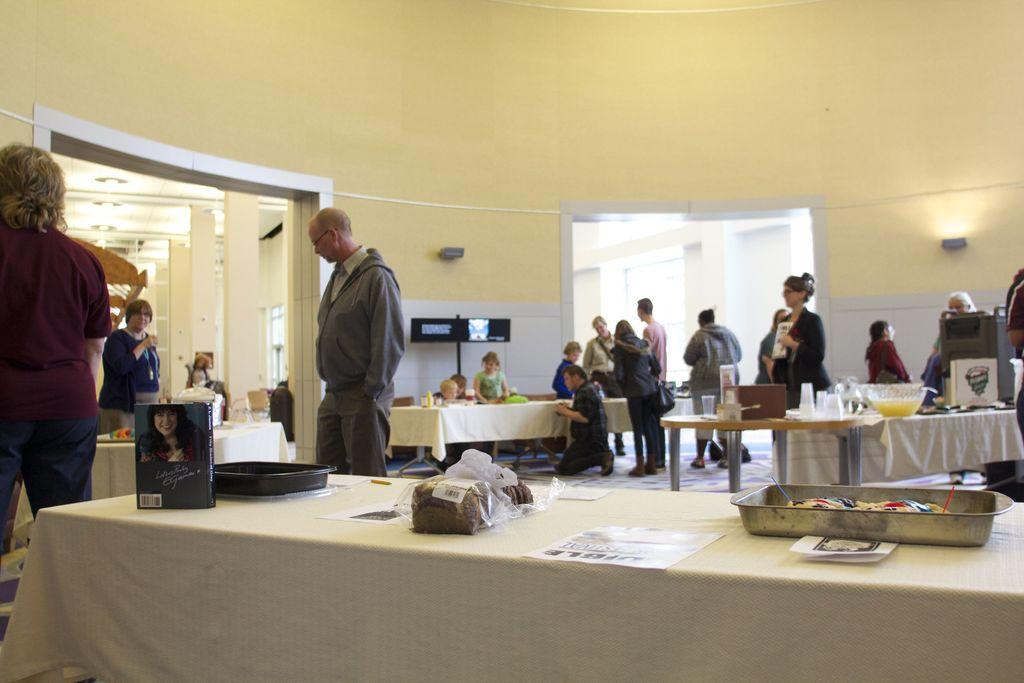What is the main piece of furniture in the image? There is a table in the image. What food items are on the table? A bread and a bowl of fish are on the table. Can you describe the people in the background of the image? The people in the background are standing and doing something. What might the people be doing in the image? It is not clear from the image what the people are doing, but they are standing and engaged in some activity. What type of grass is growing on the tray in the image? There is no grass or tray present in the image. What kind of truck can be seen in the background of the image? There is no truck visible in the image; it only shows a table with food items and people in the background. 